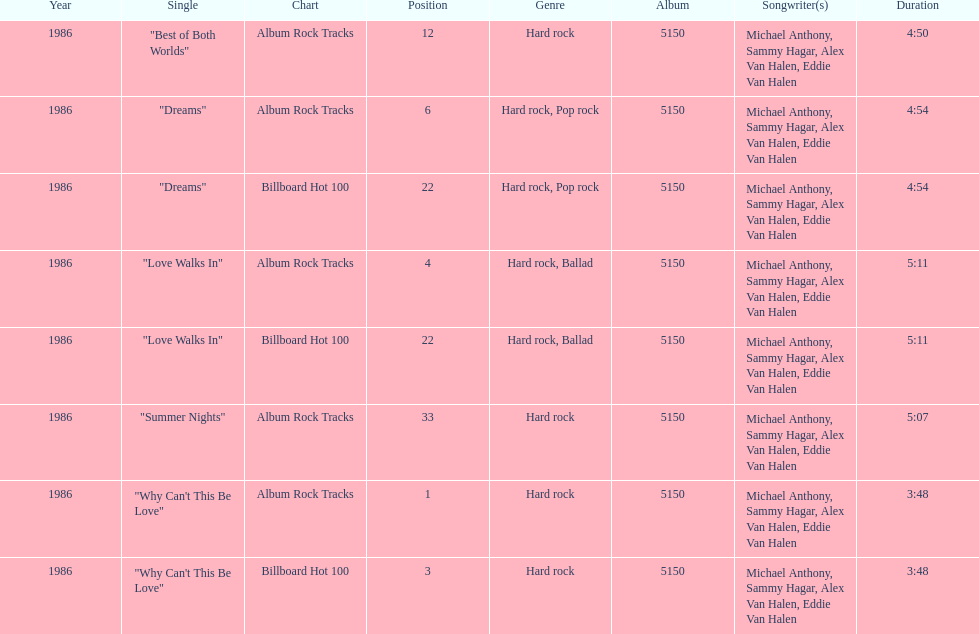Which singles each appear at position 22? Dreams, Love Walks In. 